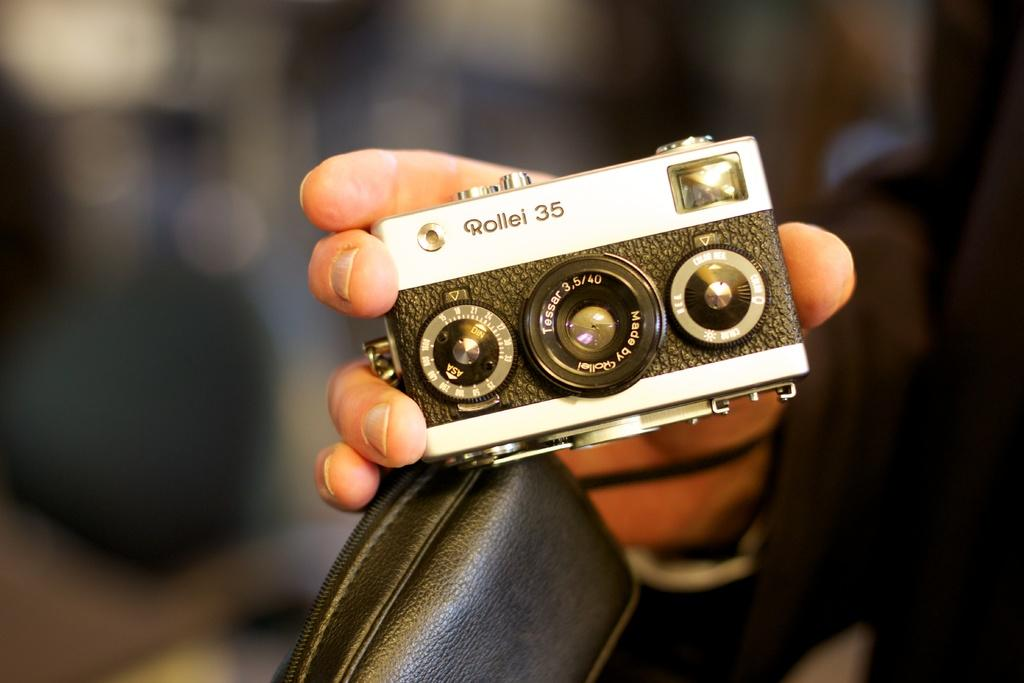<image>
Relay a brief, clear account of the picture shown. A camera has the brand name Rollei on the front of it. 